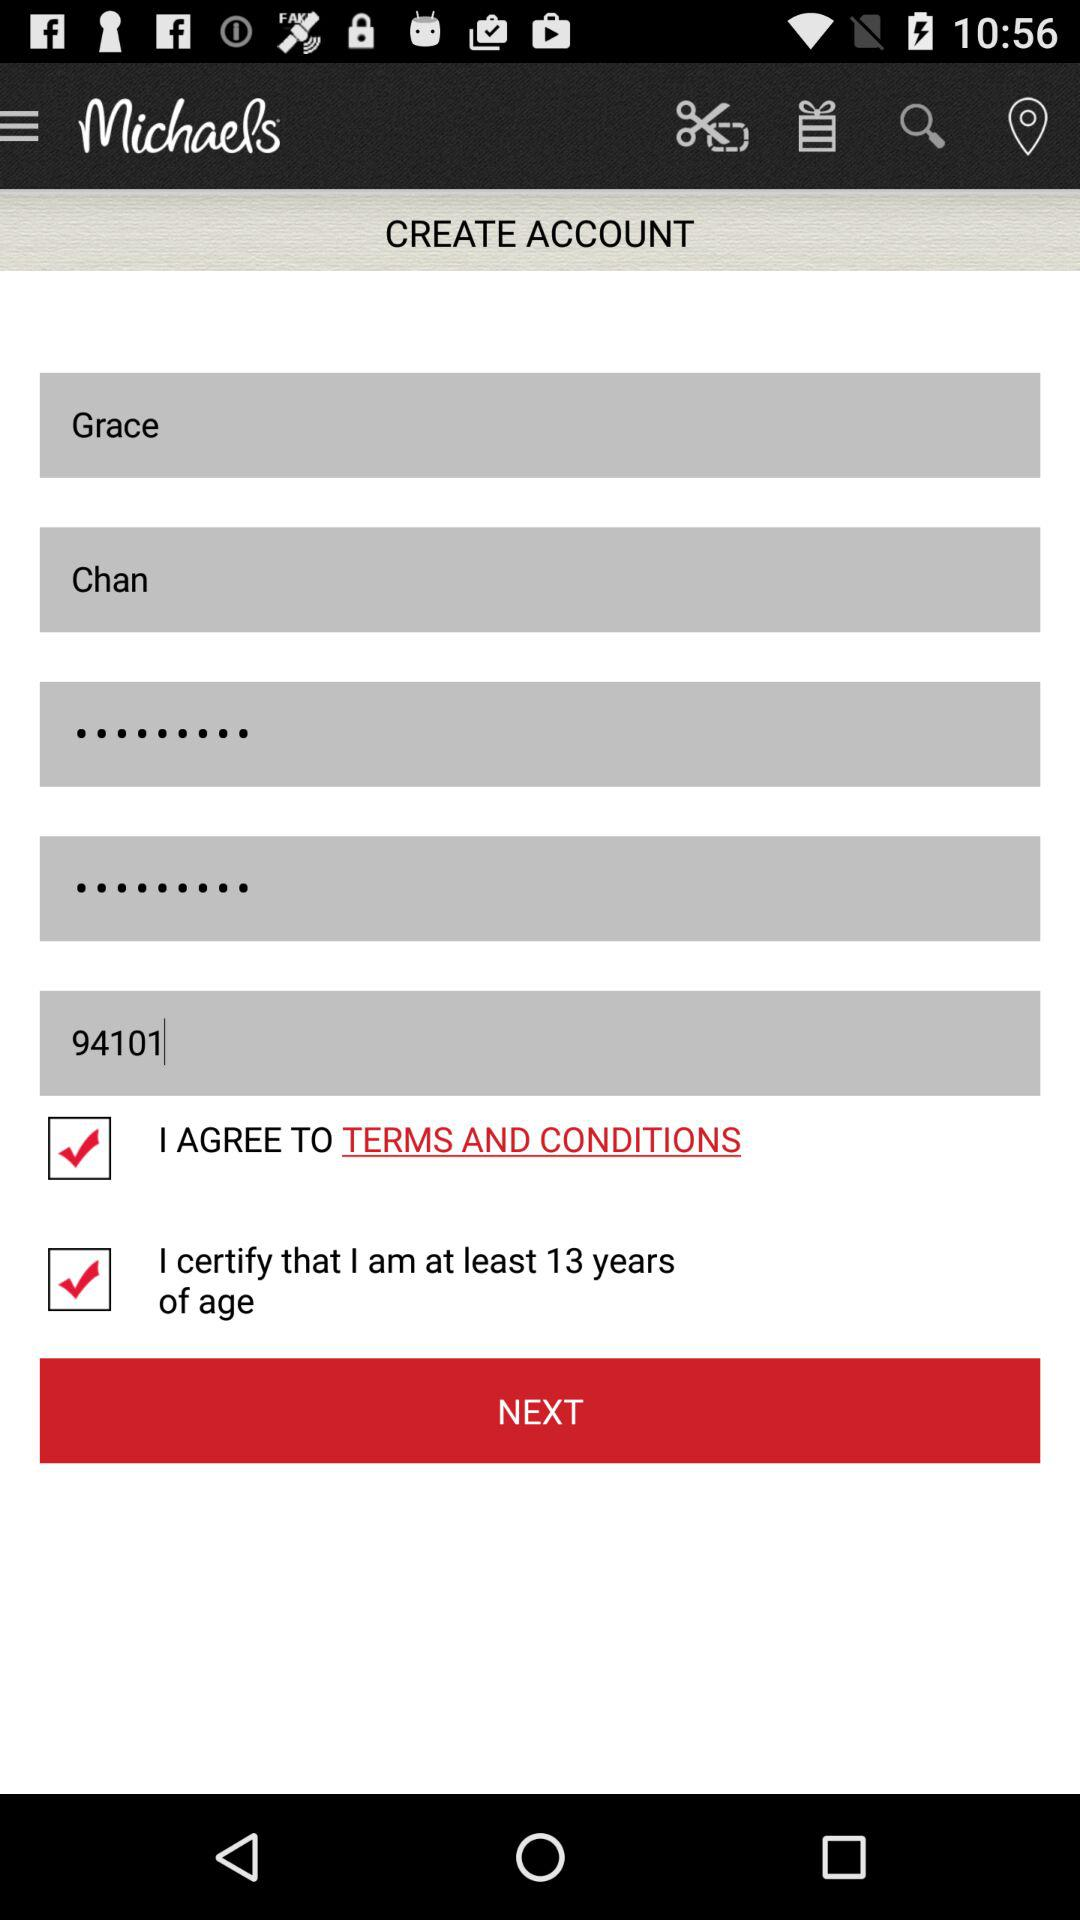How many characters are required to create a password?
When the provided information is insufficient, respond with <no answer>. <no answer> 